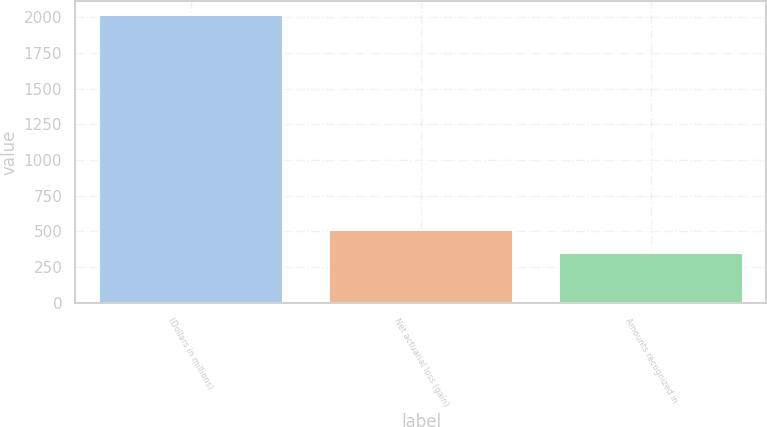<chart> <loc_0><loc_0><loc_500><loc_500><bar_chart><fcel>(Dollars in millions)<fcel>Net actuarial loss (gain)<fcel>Amounts recognized in<nl><fcel>2014<fcel>512.8<fcel>346<nl></chart> 